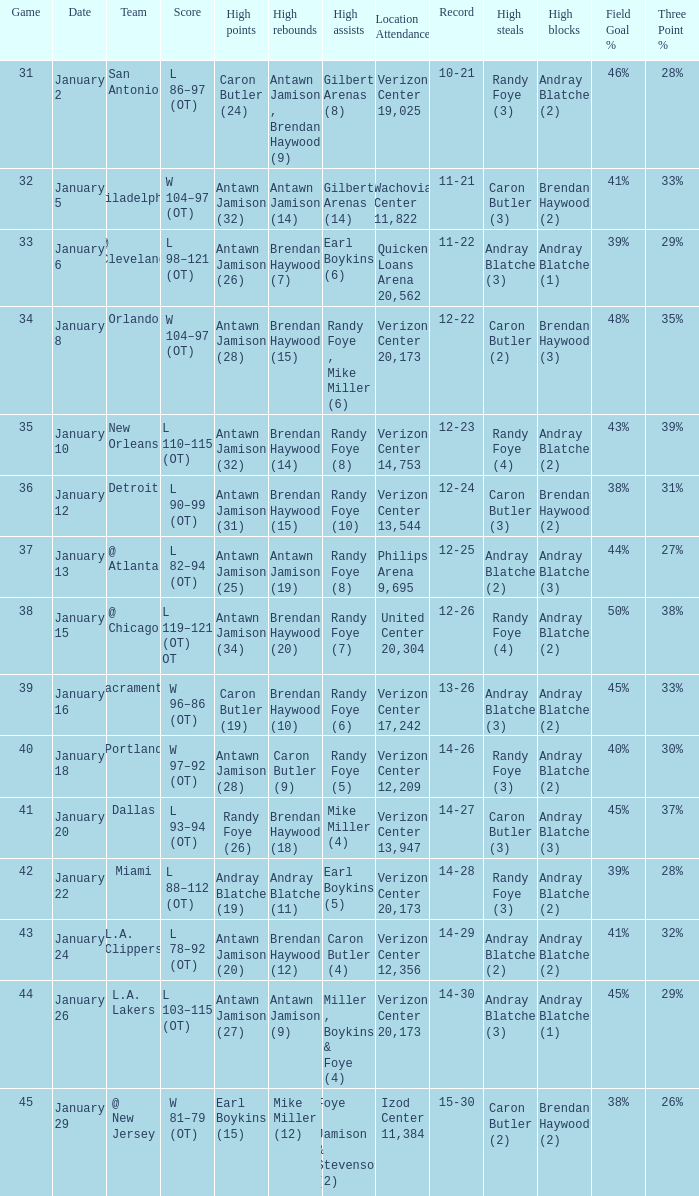Who had the highest points on January 2? Caron Butler (24). 